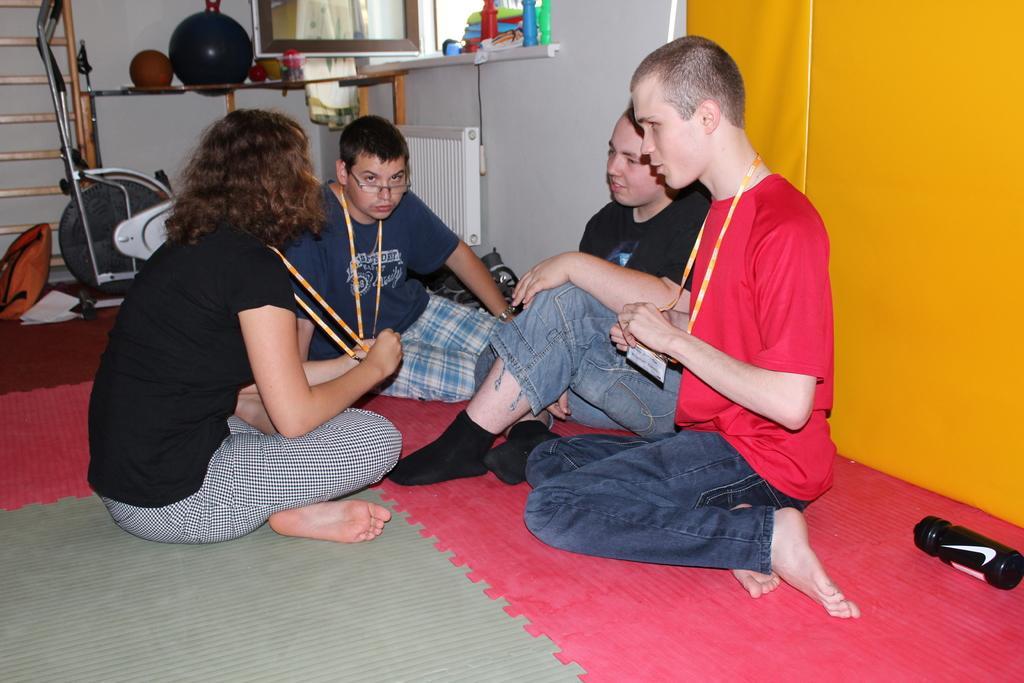Could you give a brief overview of what you see in this image? Floor with carpet. On this carpet there is a bottle. These four people are sitting on the ground. There we can see balls and things. This is a gym equipment.  